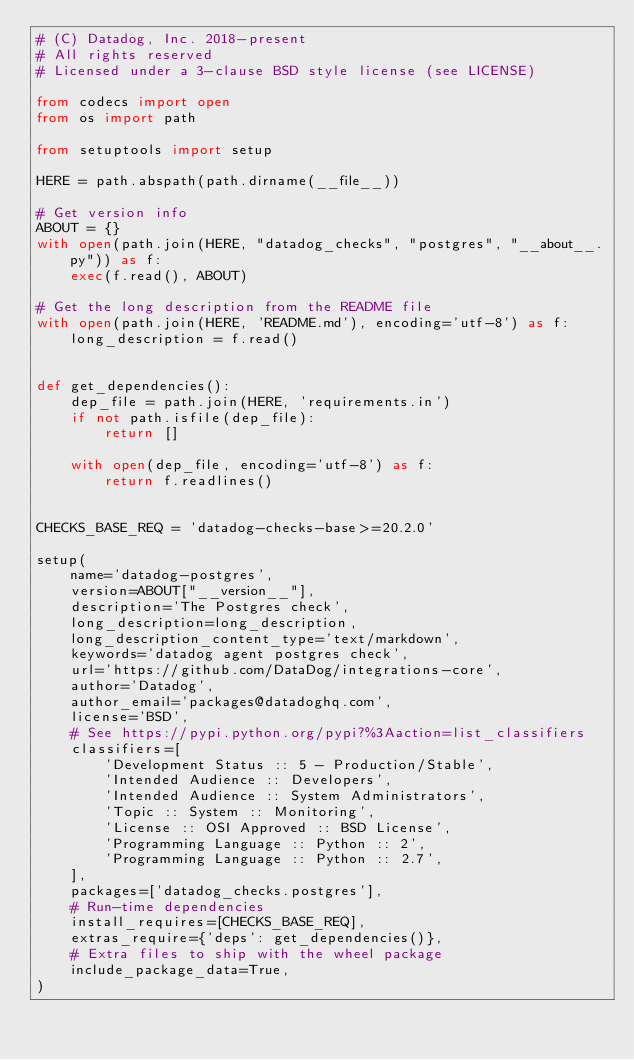Convert code to text. <code><loc_0><loc_0><loc_500><loc_500><_Python_># (C) Datadog, Inc. 2018-present
# All rights reserved
# Licensed under a 3-clause BSD style license (see LICENSE)

from codecs import open
from os import path

from setuptools import setup

HERE = path.abspath(path.dirname(__file__))

# Get version info
ABOUT = {}
with open(path.join(HERE, "datadog_checks", "postgres", "__about__.py")) as f:
    exec(f.read(), ABOUT)

# Get the long description from the README file
with open(path.join(HERE, 'README.md'), encoding='utf-8') as f:
    long_description = f.read()


def get_dependencies():
    dep_file = path.join(HERE, 'requirements.in')
    if not path.isfile(dep_file):
        return []

    with open(dep_file, encoding='utf-8') as f:
        return f.readlines()


CHECKS_BASE_REQ = 'datadog-checks-base>=20.2.0'

setup(
    name='datadog-postgres',
    version=ABOUT["__version__"],
    description='The Postgres check',
    long_description=long_description,
    long_description_content_type='text/markdown',
    keywords='datadog agent postgres check',
    url='https://github.com/DataDog/integrations-core',
    author='Datadog',
    author_email='packages@datadoghq.com',
    license='BSD',
    # See https://pypi.python.org/pypi?%3Aaction=list_classifiers
    classifiers=[
        'Development Status :: 5 - Production/Stable',
        'Intended Audience :: Developers',
        'Intended Audience :: System Administrators',
        'Topic :: System :: Monitoring',
        'License :: OSI Approved :: BSD License',
        'Programming Language :: Python :: 2',
        'Programming Language :: Python :: 2.7',
    ],
    packages=['datadog_checks.postgres'],
    # Run-time dependencies
    install_requires=[CHECKS_BASE_REQ],
    extras_require={'deps': get_dependencies()},
    # Extra files to ship with the wheel package
    include_package_data=True,
)
</code> 